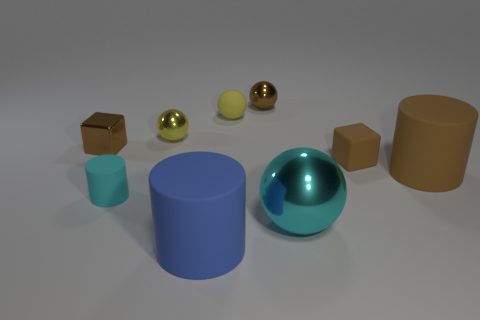Subtract all blue spheres. Subtract all red cylinders. How many spheres are left? 4 Subtract all blocks. How many objects are left? 7 Subtract all rubber cubes. Subtract all large metallic balls. How many objects are left? 7 Add 2 yellow matte objects. How many yellow matte objects are left? 3 Add 4 large gray metal cylinders. How many large gray metal cylinders exist? 4 Subtract 0 blue cubes. How many objects are left? 9 